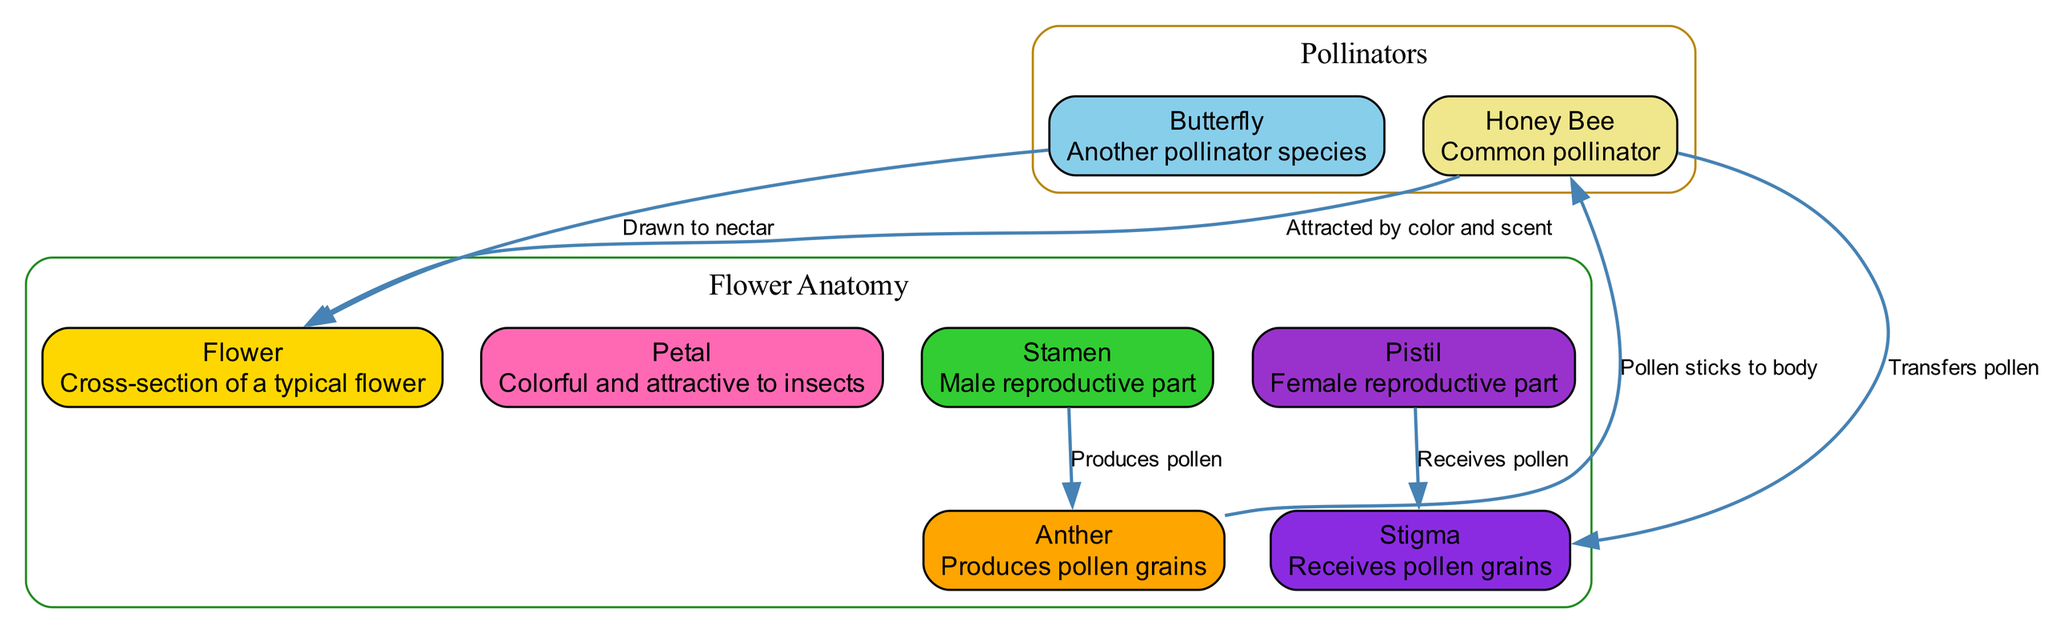What is the male reproductive part of a flower? The diagram identifies the "Stamen" as the male reproductive part of a flower, which is clearly labeled and described in the nodes.
Answer: Stamen What does the anther produce? The diagram explains that the "Anther" is responsible for producing "pollen grains," indicated in its description.
Answer: Pollen grains How do honey bees interact with the flower? The connection between "Honey Bee" and "Flower" is labeled as "Attracted by color and scent," showing how bees are drawn to the flower.
Answer: Attracted by color and scent What receives the pollen grains in the flower? According to the diagram, the "Stigma" receives the pollen grains, as indicated in the relationship between "Pistil" and "Stigma."
Answer: Stigma How many nodes represent pollinators in the diagram? The diagram includes two nodes representing pollinators: "Honey Bee" and "Butterfly." Counting these gives the total number of pollinator nodes.
Answer: 2 How is pollen transferred by the bee? The diagram shows that "Bee" transfers pollen to the "Stigma," indicating this relationship, where pollen sticks to the bee's body and is then transferred.
Answer: Transfers pollen Which part of the flower is colorful and attracts insects? The description of the "Petal" in the diagram mentions that petals are "Colorful and attractive to insects," highlighting their role in attracting pollinators.
Answer: Petal What attracts butterflies to flowers? The interaction labeled "Drawn to nectar" explains that butterflies are attracted to flowers because of the nectar they offer, as shown in the edges.
Answer: Drawn to nectar What color represents the stamen in the diagram? The color representing the "Stamen" is "Lime Green," which is identified in the custom color palette provided in the diagram.
Answer: Lime Green 